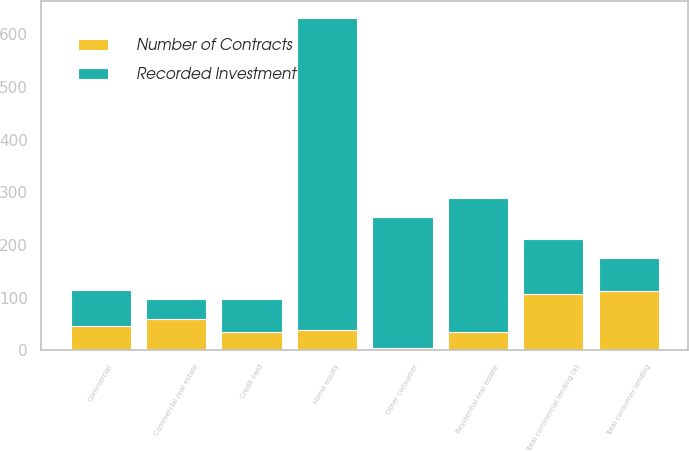<chart> <loc_0><loc_0><loc_500><loc_500><stacked_bar_chart><ecel><fcel>Commercial<fcel>Commercial real estate<fcel>Total commercial lending (a)<fcel>Home equity<fcel>Residential real estate<fcel>Credit card<fcel>Other consumer<fcel>Total consumer lending<nl><fcel>Recorded Investment<fcel>67<fcel>38<fcel>105<fcel>592<fcel>255<fcel>63<fcel>249<fcel>63<nl><fcel>Number of Contracts<fcel>47<fcel>59<fcel>106<fcel>39<fcel>35<fcel>34<fcel>4<fcel>112<nl></chart> 